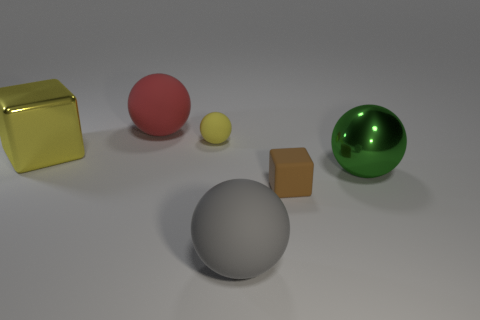Is the color of the metal thing right of the gray matte thing the same as the small object that is in front of the tiny yellow thing?
Provide a succinct answer. No. There is a big ball that is both on the left side of the green metallic thing and behind the tiny block; what material is it made of?
Offer a terse response. Rubber. What is the color of the tiny block?
Your answer should be compact. Brown. What number of other objects are the same shape as the green metal object?
Provide a succinct answer. 3. Is the number of yellow cubes that are in front of the tiny yellow object the same as the number of big shiny balls that are in front of the green metal ball?
Ensure brevity in your answer.  No. What material is the yellow block?
Your answer should be very brief. Metal. There is a cube behind the green shiny ball; what material is it?
Provide a succinct answer. Metal. Are there more big gray balls that are in front of the large red object than small yellow metallic cylinders?
Make the answer very short. Yes. There is a yellow rubber object behind the large ball that is to the right of the brown cube; are there any large matte spheres in front of it?
Give a very brief answer. Yes. There is a gray rubber thing; are there any large gray spheres behind it?
Provide a succinct answer. No. 